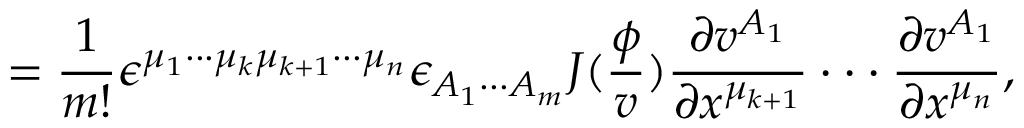<formula> <loc_0><loc_0><loc_500><loc_500>= \frac { 1 } m ! } \epsilon ^ { \mu _ { 1 } \cdot \cdot \cdot \mu _ { k } \mu _ { k + 1 } \cdot \cdot \cdot \mu _ { n } } \epsilon _ { A _ { 1 } \cdot \cdot \cdot A _ { m } } J ( \frac { \phi } { v } ) \frac { \partial v ^ { A _ { 1 } } } { \partial x ^ { \mu _ { k + 1 } } } \cdot \cdot \cdot \frac { \partial v ^ { A _ { 1 } } } { \partial x ^ { \mu _ { n } } } ,</formula> 